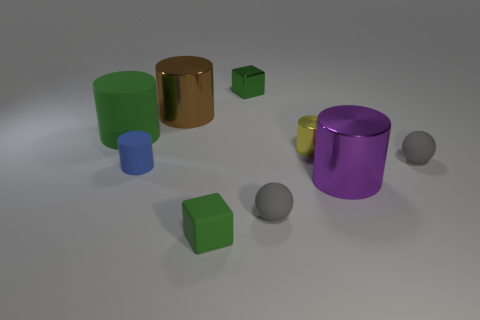Subtract all large green cylinders. How many cylinders are left? 4 Subtract all brown cylinders. How many cylinders are left? 4 Subtract all cylinders. How many objects are left? 4 Subtract 1 cubes. How many cubes are left? 1 Subtract all red cylinders. Subtract all blue spheres. How many cylinders are left? 5 Subtract all yellow cubes. How many yellow cylinders are left? 1 Subtract all large matte things. Subtract all brown things. How many objects are left? 7 Add 8 yellow metal things. How many yellow metal things are left? 9 Add 2 small matte blocks. How many small matte blocks exist? 3 Subtract 1 blue cylinders. How many objects are left? 8 